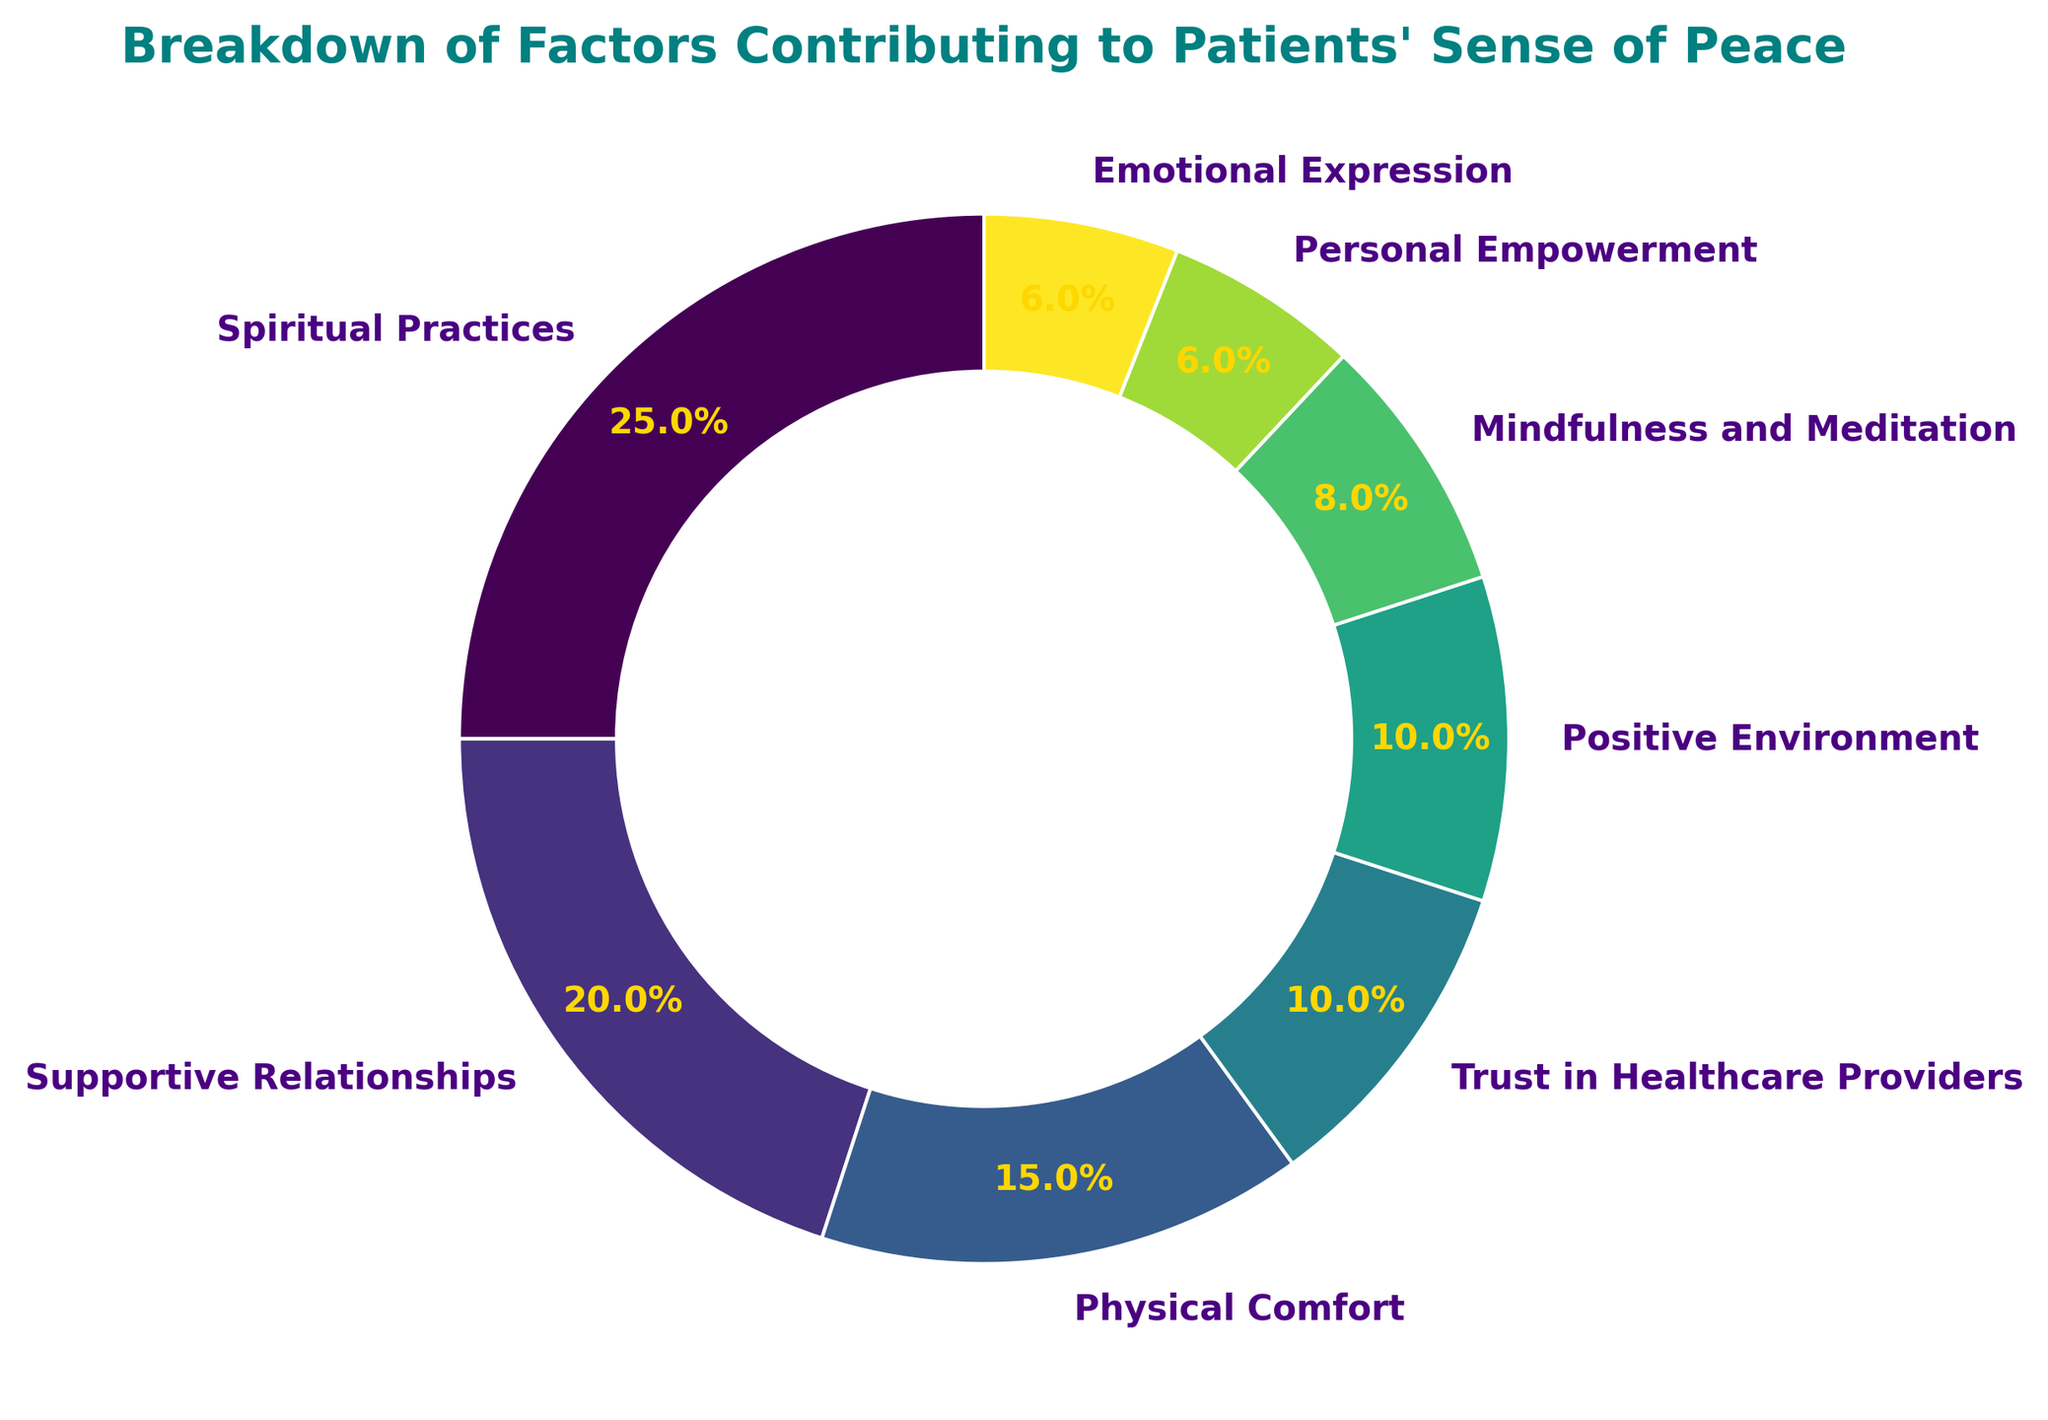How many categories contribute more than 10% to patient's sense of peace? Identify each category contributing more than 10%, add up their percentages: Spiritual Practices (25%), Supportive Relationships (20%), Physical Comfort (15%)
Answer: 3 What is the combined total percentage of Trust in Healthcare Providers, Positive Environment, and Personal Empowerment? Sum of percentages in these categories: Trust in Healthcare Providers (10%) + Positive Environment (10%) + Personal Empowerment (6%) = 26%
Answer: 26% Which category has the smallest contribution to patients' sense of peace? Identify the category with the smallest percentage: Emotional Expression (6%)
Answer: Emotional Expression How much does Supportive Relationships contribute more than Mindfulness and Meditation? Subtract percentage of Mindfulness and Meditation (8%) from Supportive Relationships (20%): 20% - 8% = 12%
Answer: 12% Which category is represented by a color near the lighter green range on the ring chart? Lighter shades of green typically appear in sequence; Positive Environment sits in the lime-green area
Answer: Positive Environment What is the total percentage of the two largest contributing factors? Sum up the percentages of Spiritual Practices (25%) and Supportive Relationships (20%): 25% + 20% = 45%
Answer: 45% What percentage does Physical Comfort contribute to the patients' sense of peace compared to Emotional Expression? Find the difference between Physical Comfort (15%) and Emotional Expression (6%): 15% - 6% = 9%
Answer: 9% Which category has a contribution percentage closest to 10%? Identify the category with a percentage nearest to 10%: both Trust in Healthcare Providers (10%) and Positive Environment (10%)
Answer: Trust in Healthcare Providers, Positive Environment 